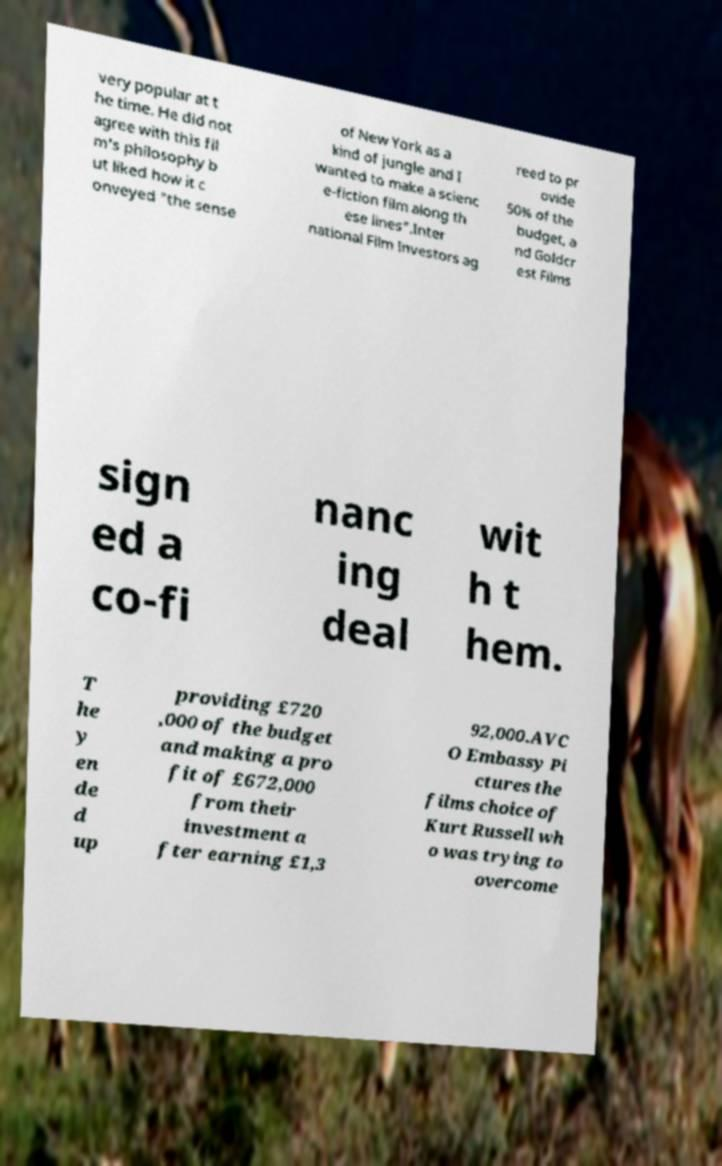Can you read and provide the text displayed in the image?This photo seems to have some interesting text. Can you extract and type it out for me? very popular at t he time. He did not agree with this fil m's philosophy b ut liked how it c onveyed "the sense of New York as a kind of jungle and I wanted to make a scienc e-fiction film along th ese lines".Inter national Film Investors ag reed to pr ovide 50% of the budget, a nd Goldcr est Films sign ed a co-fi nanc ing deal wit h t hem. T he y en de d up providing £720 ,000 of the budget and making a pro fit of £672,000 from their investment a fter earning £1,3 92,000.AVC O Embassy Pi ctures the films choice of Kurt Russell wh o was trying to overcome 